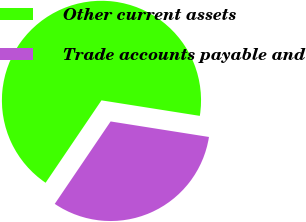<chart> <loc_0><loc_0><loc_500><loc_500><pie_chart><fcel>Other current assets<fcel>Trade accounts payable and<nl><fcel>68.01%<fcel>31.99%<nl></chart> 